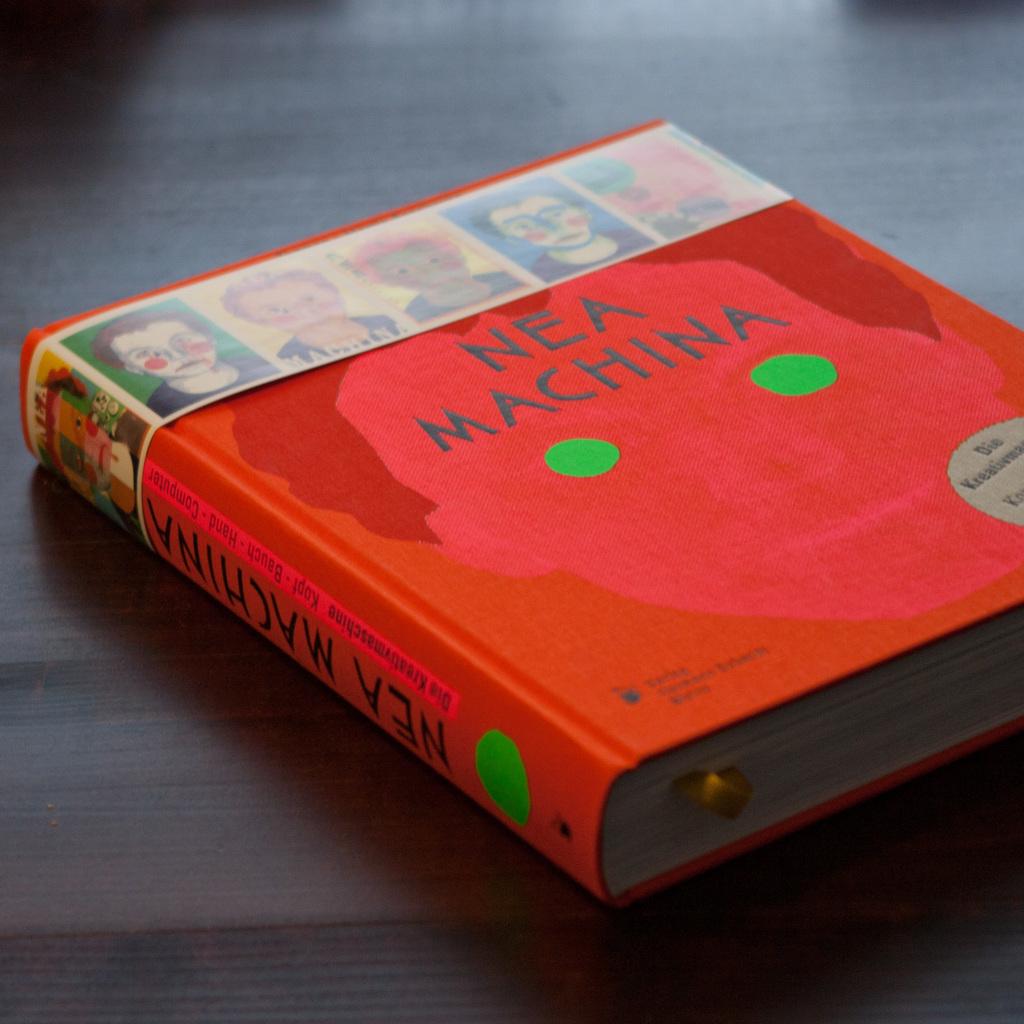What is the title of this book?
Offer a terse response. Nea machina. Who wrote the book?
Provide a short and direct response. Nea machina. 